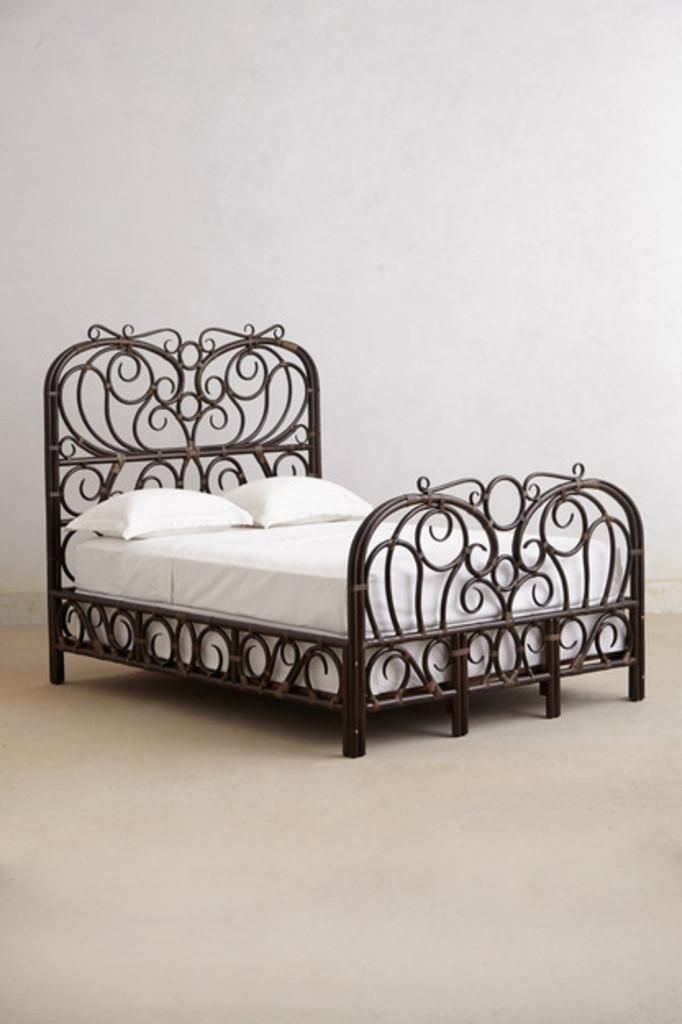What is the main object in the center of the image? There is a bed in the middle of the image. What color is the bed sheet? The bed sheet is white. What other white items can be seen on the bed? There are white color pillows on the bed. Where is the bed located? The bed is on a floor. What color is the wall in the background? The wall in the background is white. Where is the calendar hanging on the wall in the image? There is no calendar present in the image. What type of hook is used to hang the shoes on the wall in the image? There are no shoes or hooks present in the image. 